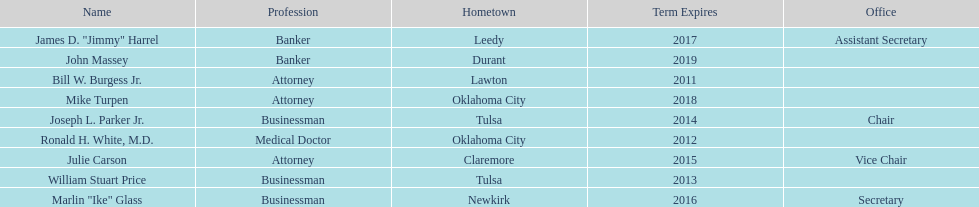Total number of members from lawton and oklahoma city 3. 